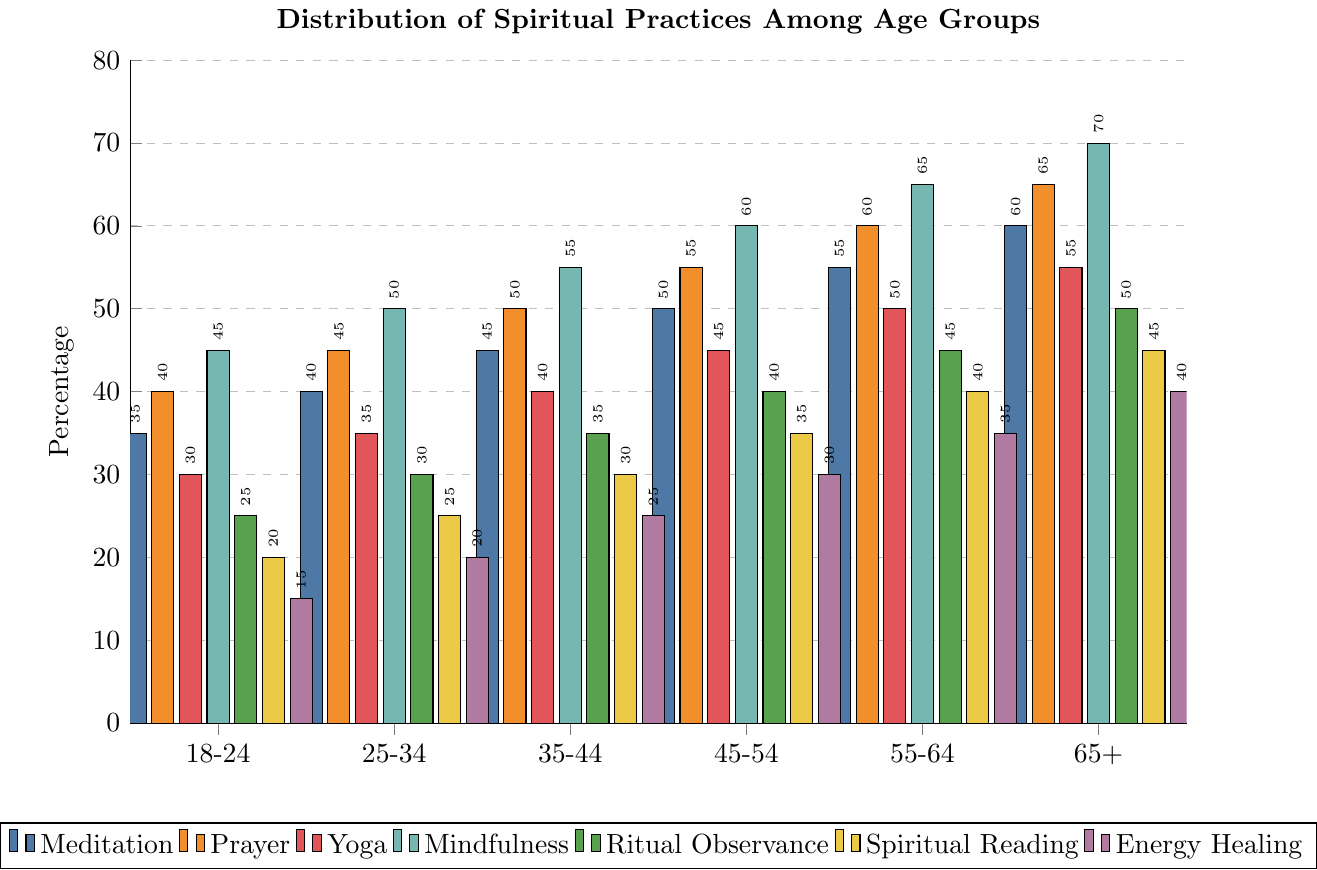Which age group has the highest percentage of people practicing mindfulness? The highest bar for mindfulness is for the 65+ age group, indicating they have the highest percentage practicing mindfulness.
Answer: 65+ Which spiritual practice is the least popular among the 18-24 age group? The shortest bar for the 18-24 age group represents Energy Healing, indicating it has the lowest percentage.
Answer: Energy Healing What is the total percentage of people practicing Meditation and Prayer in the 45-54 age group? The percentage for Meditation in the 45-54 age group is 50, and for Prayer, it is 55. Adding these together gives 50 + 55 = 105.
Answer: 105 Compare the popularity of Yoga and Spiritual Reading in the 25-34 age group. Which one is more popular? The bar for Yoga in the 25-34 age group is higher than the bar for Spiritual Reading, indicating Yoga is more popular.
Answer: Yoga What trend do you observe in the percentage of people practicing Ritual Observance as age increases? The height of bars representing Ritual Observance steadily increases with age, indicating a positive trend where older age groups observe rituals more.
Answer: Increases How much higher is the percentage of people practicing Energy Healing in the 65+ age group compared to the 18-24 age group? The percentage for Energy Healing in the 65+ age group is 40, whereas in the 18-24 age group it’s 15. Subtracting these gives 40 - 15 = 25.
Answer: 25 Among all age groups, which spiritual practice shows the most significant increase in percentage? Mindfulness shows the most significant increase as the age increases, from 45% in the 18-24 group to 70% in the 65+ group.
Answer: Mindfulness Which age group shows equal percentage for Yoga and Spiritual Reading? The 55-64 age group shows equal percentages for both Yoga and Spiritual Reading, both at 40.
Answer: 55-64 If we combine the percentages of people practicing Yoga and Mindfulness in the 35-44 age group, what is the total? The percentage for Yoga is 40 and for Mindfulness, it is 55 in the 35-44 age group. Adding these gives 40 + 55 = 95.
Answer: 95 